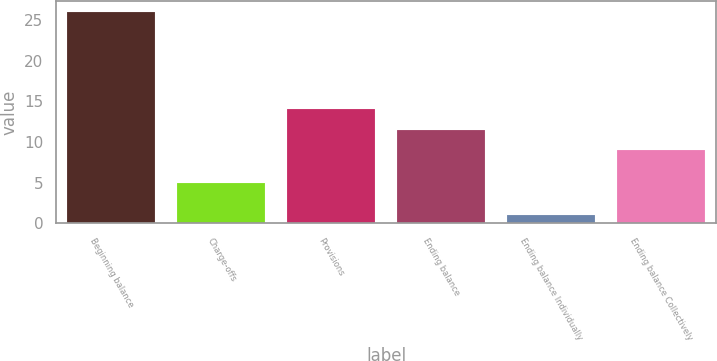<chart> <loc_0><loc_0><loc_500><loc_500><bar_chart><fcel>Beginning balance<fcel>Charge-offs<fcel>Provisions<fcel>Ending balance<fcel>Ending balance Individually<fcel>Ending balance Collectively<nl><fcel>26<fcel>5<fcel>14<fcel>11.5<fcel>1<fcel>9<nl></chart> 